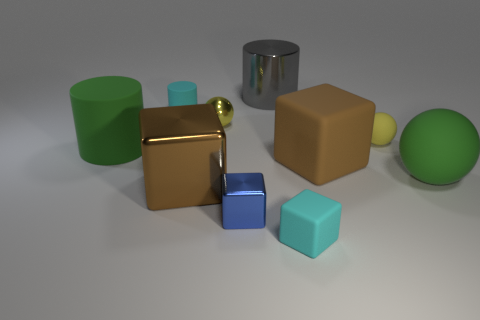Subtract all tiny cyan blocks. How many blocks are left? 3 Subtract all green spheres. How many brown cubes are left? 2 Subtract all cyan cylinders. How many cylinders are left? 2 Subtract 1 cylinders. How many cylinders are left? 2 Subtract all yellow cubes. Subtract all red spheres. How many cubes are left? 4 Subtract all blocks. How many objects are left? 6 Subtract all cyan objects. Subtract all large brown matte cubes. How many objects are left? 7 Add 5 rubber balls. How many rubber balls are left? 7 Add 3 big objects. How many big objects exist? 8 Subtract 1 gray cylinders. How many objects are left? 9 